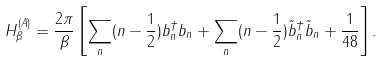<formula> <loc_0><loc_0><loc_500><loc_500>H ^ { ( A ) } _ { \beta } = \frac { 2 \pi } { \beta } \left [ \sum _ { n } ( n - \frac { 1 } { 2 } ) b ^ { \dagger } _ { n } b _ { n } + \sum _ { n } ( n - \frac { 1 } { 2 } ) \tilde { b } ^ { \dagger } _ { n } \tilde { b } _ { n } + \frac { 1 } { 4 8 } \right ] .</formula> 